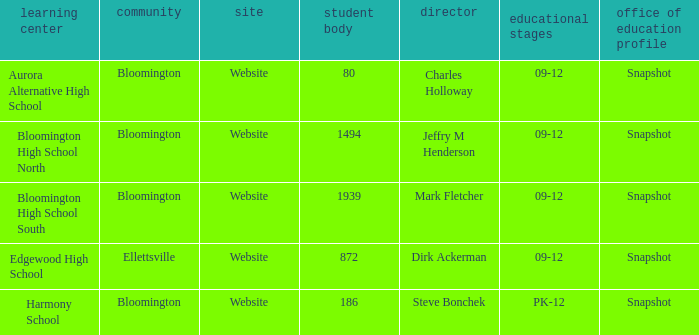Where's the school that Mark Fletcher is the principal of? Bloomington. 